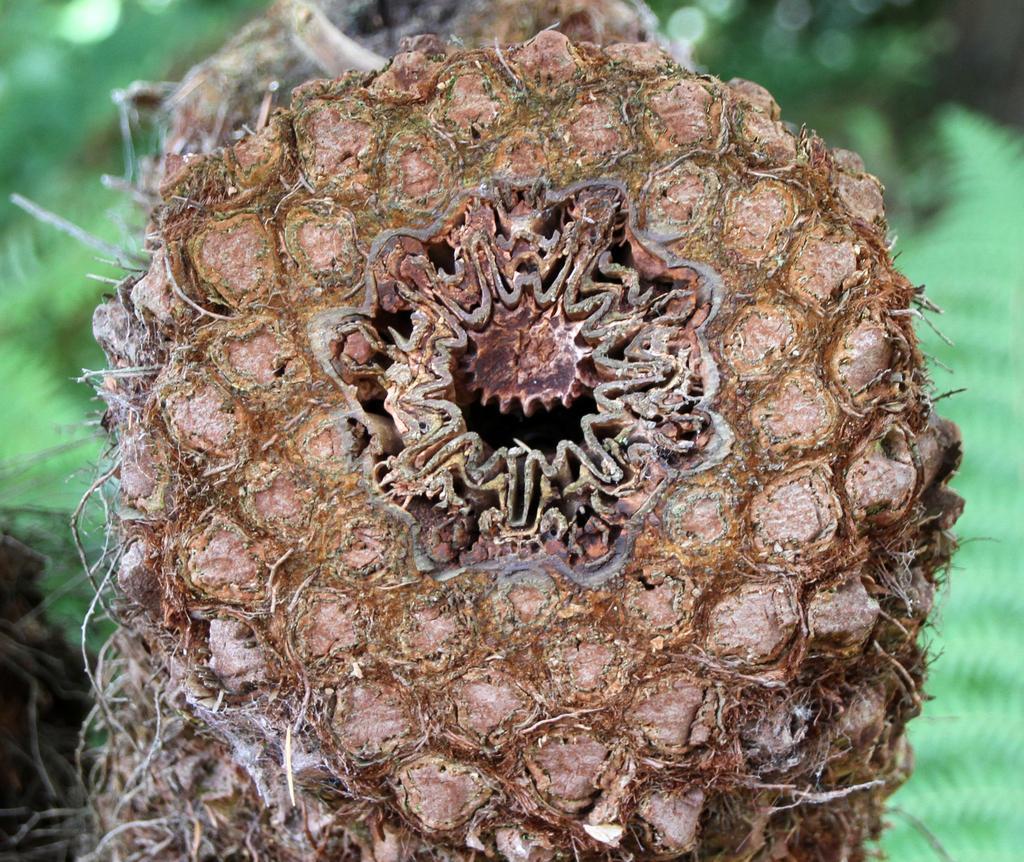How would you summarize this image in a sentence or two? In this image I can see the brown colored object and in the background I can see few blurry objects which are green in color. 